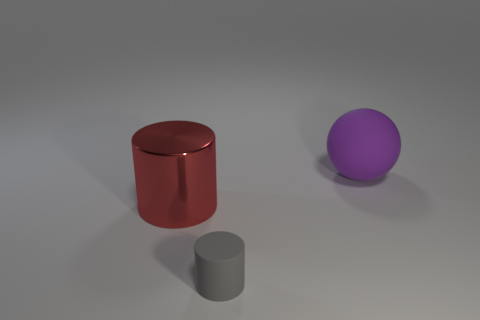Add 2 metal cylinders. How many objects exist? 5 Subtract all cylinders. How many objects are left? 1 Add 3 matte objects. How many matte objects exist? 5 Subtract 0 green cubes. How many objects are left? 3 Subtract all large matte balls. Subtract all rubber objects. How many objects are left? 0 Add 2 small gray matte things. How many small gray matte things are left? 3 